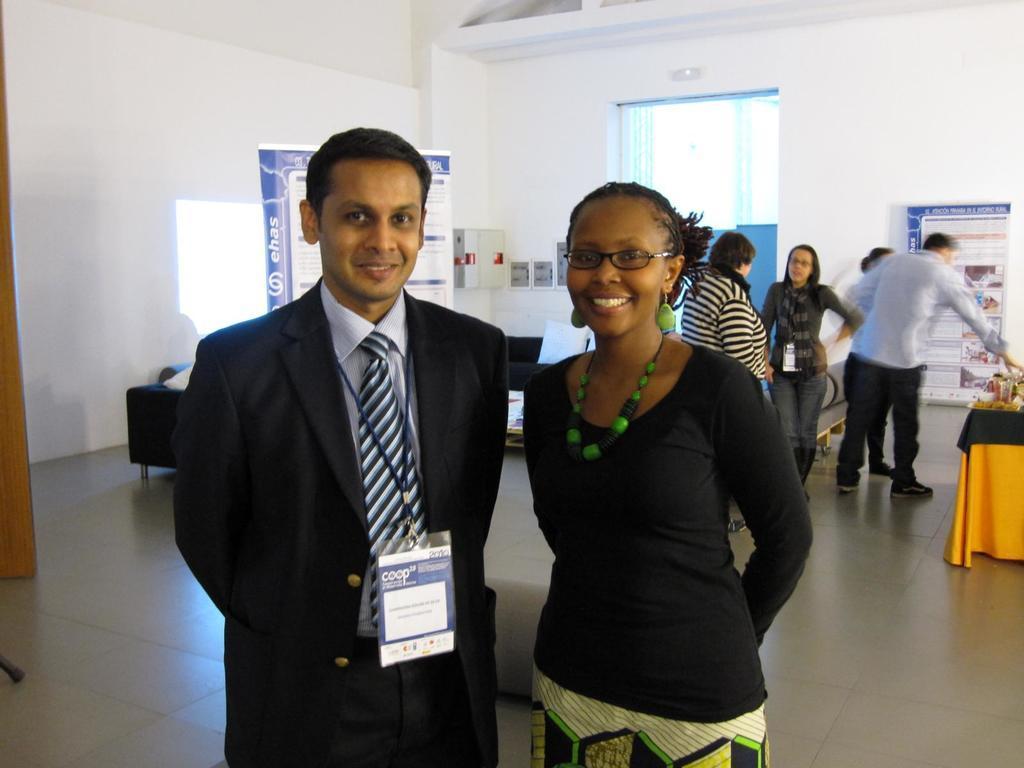Describe this image in one or two sentences. In the center of the image there are two people standing. In the background of the image there is wall. There is a banner. There are people standing. There is a window. At the top of the image there is ceiling. To the right side of the image there is a table on which there are objects. At the bottom of the image there is floor. 